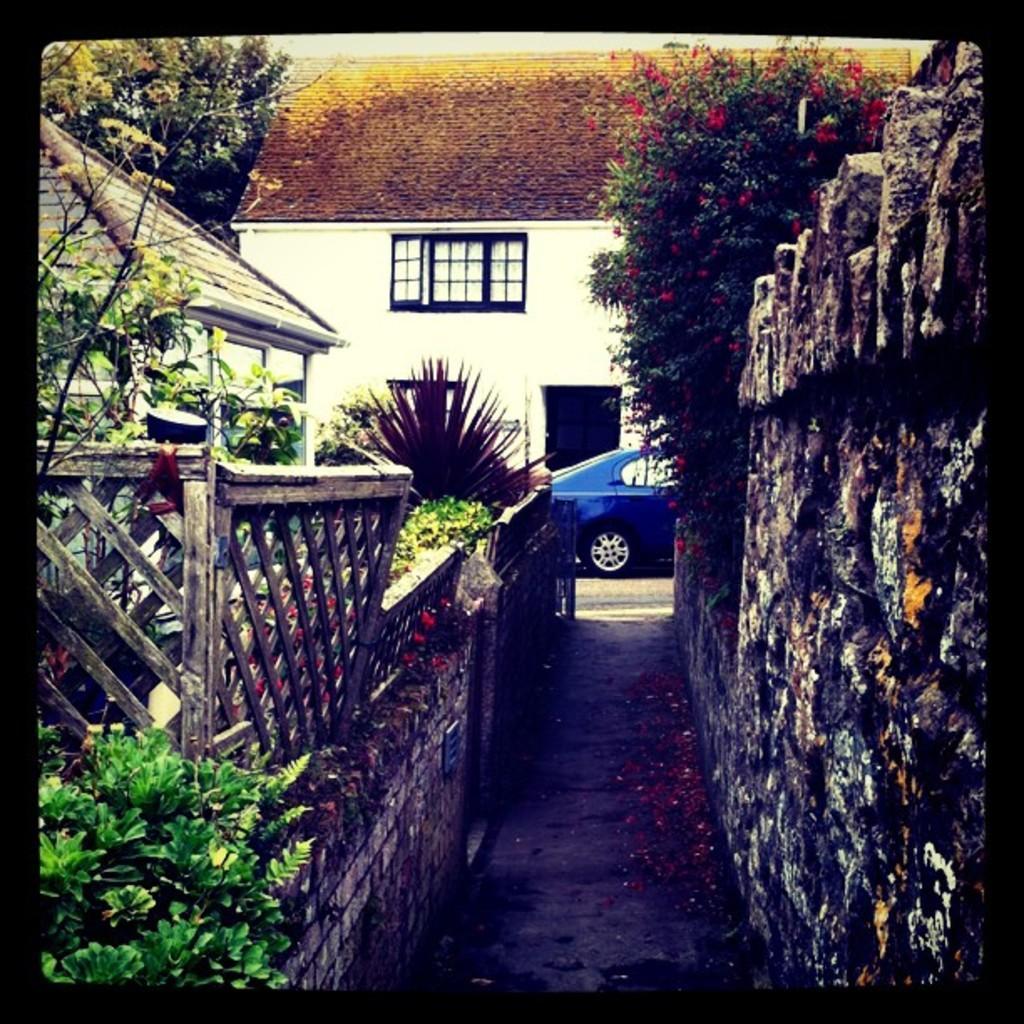Please provide a concise description of this image. In this image we can see the houses, there are some plants, trees, flowers, wooden fence and a vehicle, also we can see the wall. 